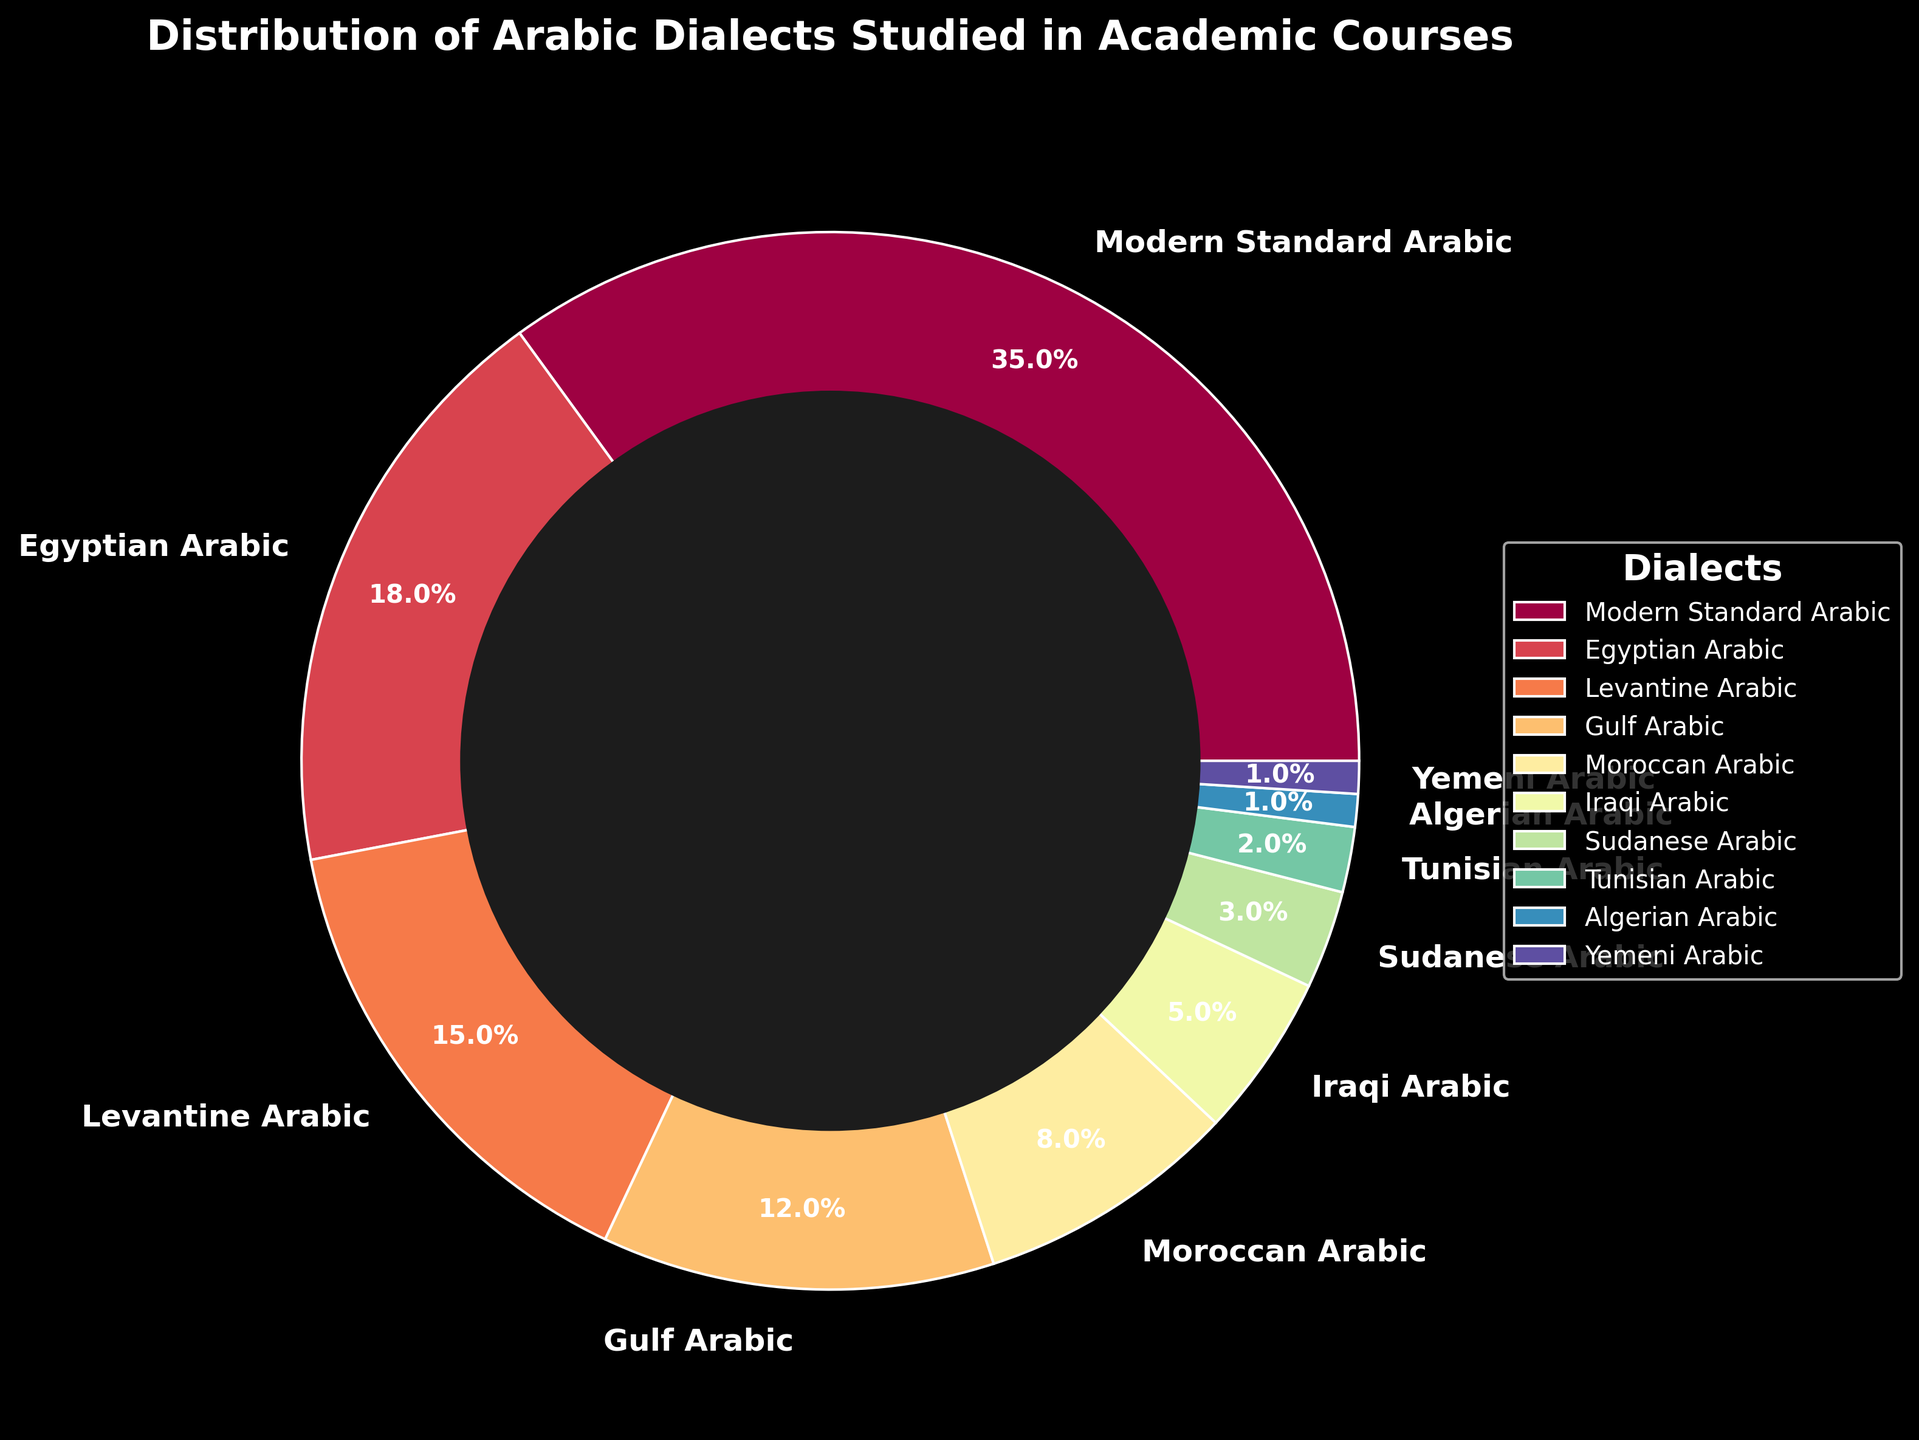What percentage of academic courses study Egyptian Arabic? Refer to the pie chart segment labeled "Egyptian Arabic" to find its percentage.
Answer: 18% Which Arabic dialect is studied more in academic courses, Levantine Arabic or Gulf Arabic? Compare the percentages of Levantine Arabic and Gulf Arabic from the pie chart. Levantine Arabic has 15% and Gulf Arabic has 12%.
Answer: Levantine Arabic What is the combined percentage of courses studying Iraqi Arabic and Moroccan Arabic? Sum the percentages of Iraqi Arabic (5%) and Moroccan Arabic (8%) from the chart. 5% + 8% = 13%.
Answer: 13% Which dialect has the smallest percentage of academic courses studying it, and what is that percentage? Identify the smallest segment in the pie chart, which corresponds to Algerian Arabic and Yemeni Arabic, both with 1%.
Answer: Algerian Arabic and Yemeni Arabic, 1% How many times greater is the percentage of courses studying Modern Standard Arabic compared to the percentage studying Sudanese Arabic? Divide the percentage of Modern Standard Arabic (35%) by the percentage of Sudanese Arabic (3%). 35% / 3% = ~11.67.
Answer: ~11.67 times Rank the top three most studied Arabic dialects in academic courses. Examine the three largest segments in the pie chart, which are Modern Standard Arabic (35%), Egyptian Arabic (18%), and Levantine Arabic (15%).
Answer: 1. Modern Standard Arabic, 2. Egyptian Arabic, 3. Levantine Arabic What is the average percentage of courses studying Gulf Arabic, Sudanese Arabic, and Tunisian Arabic? Sum the percentages of Gulf Arabic (12%), Sudanese Arabic (3%), and Tunisian Arabic (2%), then divide by the number of dialects (3). (12 + 3 + 2) / 3 = 17 / 3 = ~5.67%.
Answer: ~5.67% Does the sum of the percentages for Moroccan Arabic, Iraqi Arabic, and Tunisian Arabic exceed the percentage for Egyptian Arabic? Sum the percentages of Moroccan Arabic (8%), Iraqi Arabic (5%), and Tunisian Arabic (2%), and compare it to Egyptian Arabic (18%). 8% + 5% + 2% = 15%, which is less than 18%.
Answer: No 